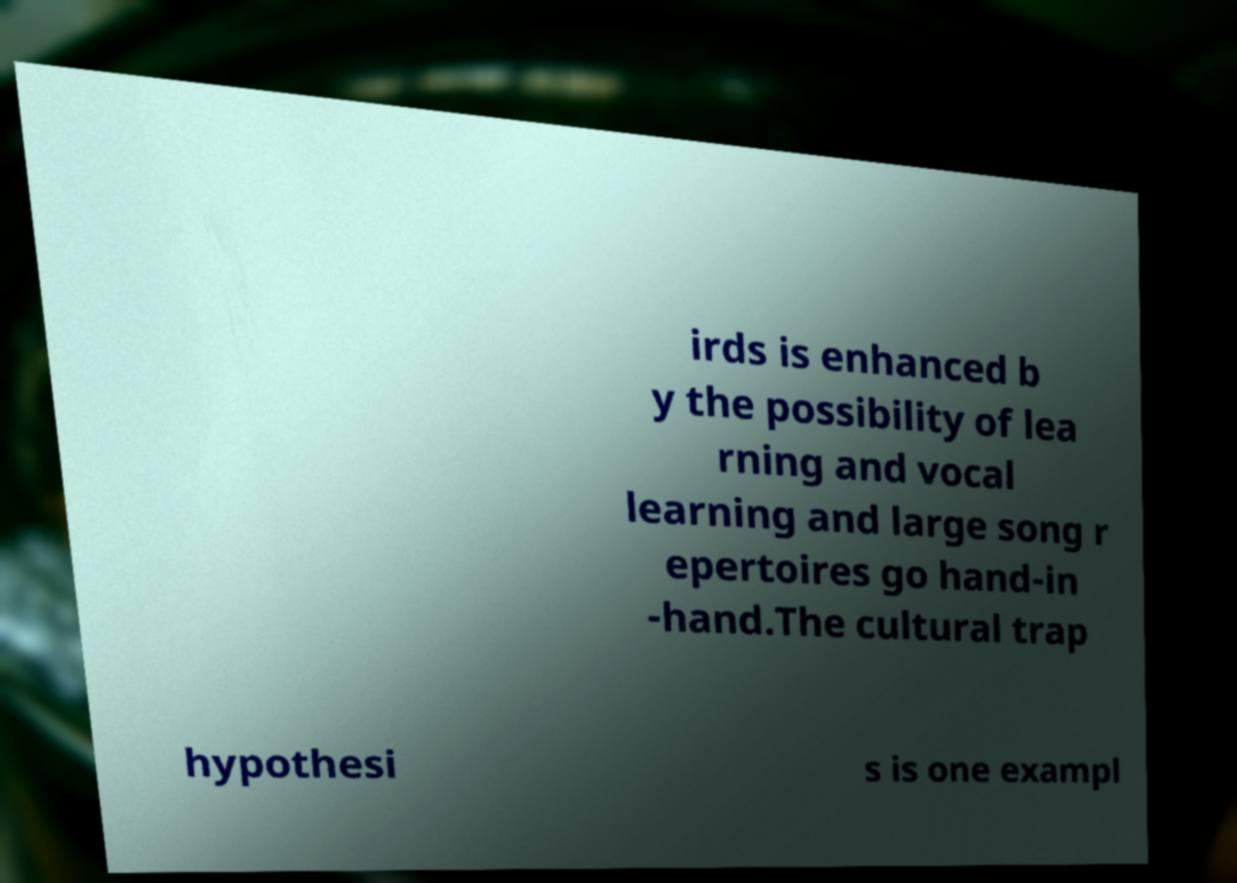I need the written content from this picture converted into text. Can you do that? irds is enhanced b y the possibility of lea rning and vocal learning and large song r epertoires go hand-in -hand.The cultural trap hypothesi s is one exampl 